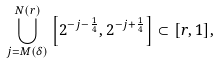<formula> <loc_0><loc_0><loc_500><loc_500>\bigcup _ { j = M ( \delta ) } ^ { N ( r ) } \left [ 2 ^ { - j - \frac { 1 } { 4 } } , 2 ^ { - j + \frac { 1 } { 4 } } \right ] \subset [ r , 1 ] ,</formula> 